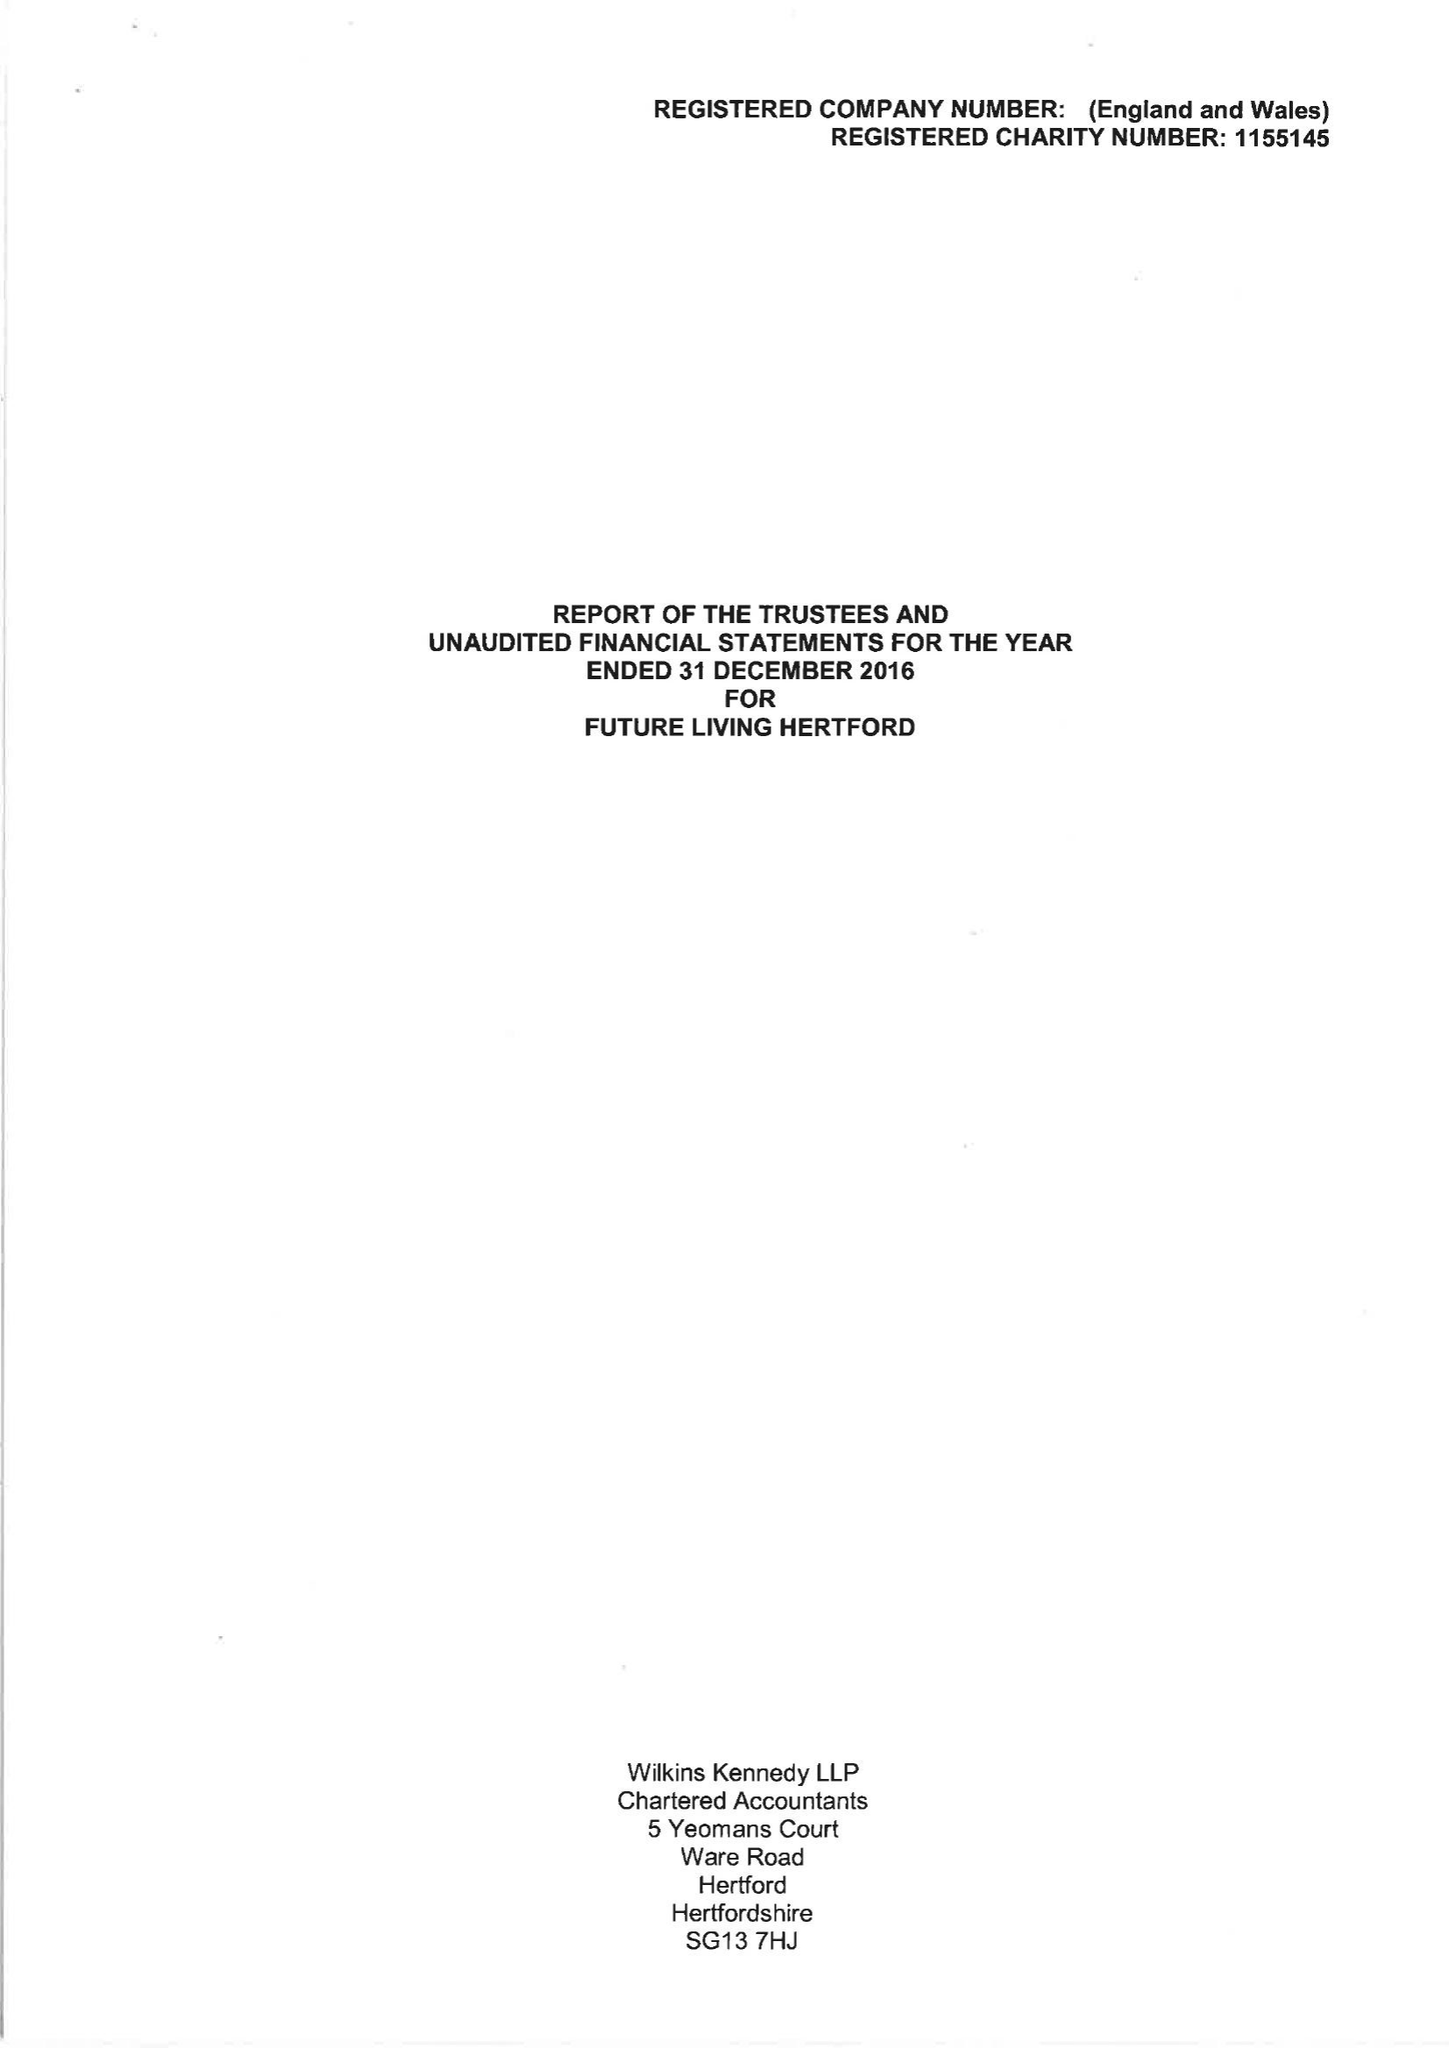What is the value for the address__postcode?
Answer the question using a single word or phrase. SG14 1PN 